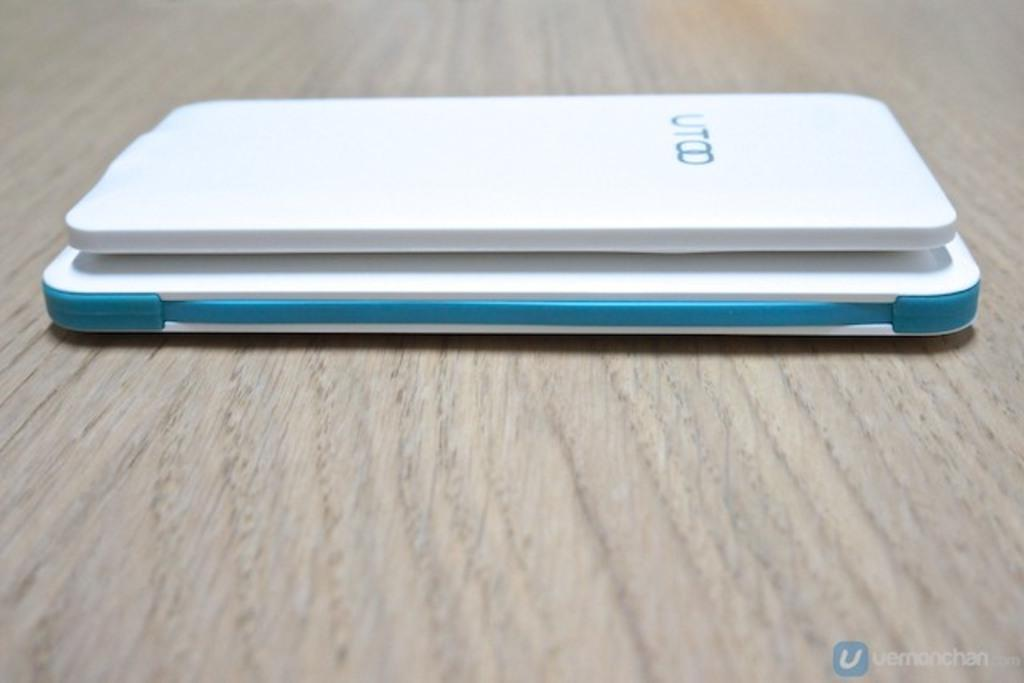<image>
Write a terse but informative summary of the picture. A white UTOO cell phone laying on top of another white and teal phone face down. 